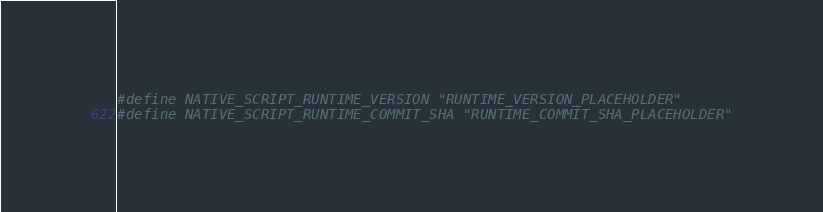Convert code to text. <code><loc_0><loc_0><loc_500><loc_500><_C_>#define NATIVE_SCRIPT_RUNTIME_VERSION "RUNTIME_VERSION_PLACEHOLDER"
#define NATIVE_SCRIPT_RUNTIME_COMMIT_SHA "RUNTIME_COMMIT_SHA_PLACEHOLDER"
</code> 